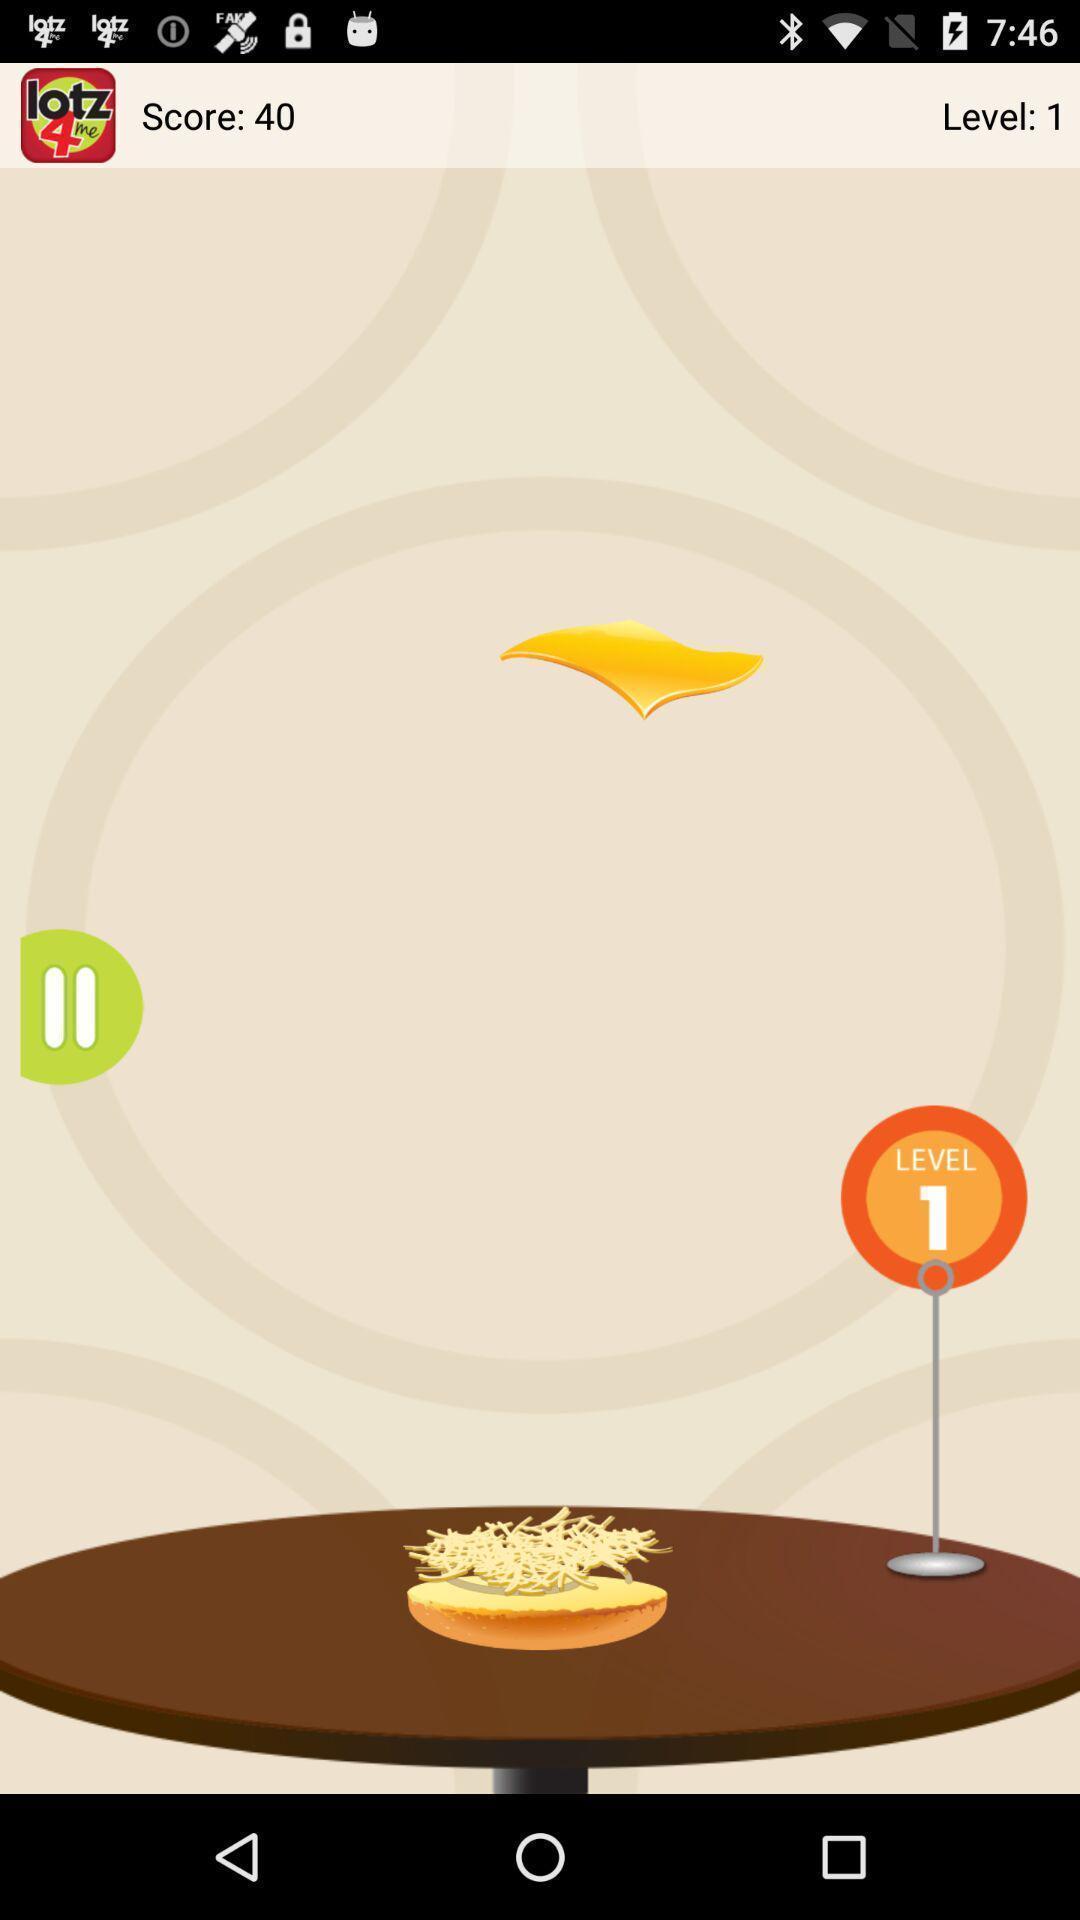Describe the key features of this screenshot. Screen displaying the level number of a game. 